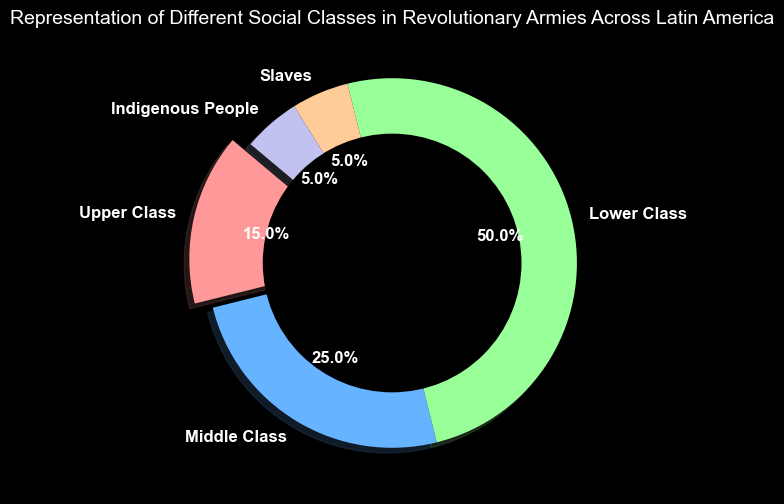What percentage of the revolutionary armies were comprised of the Lower Class? By looking at the figure, the section labeled "Lower Class" shows the percentage representation. The slice labeled "Lower Class" is marked with a certain percentage.
Answer: 50% Which social class had the smallest representation in the revolutionary armies? The figure shows various slices with different sizes corresponding to percentages. The smallest slices are those representing "Slaves" and "Indigenous People," both having the smallest percentage.
Answer: Slaves and Indigenous People Which had a higher representation in the revolutionary armies: Upper Class or Middle Class? By observing the slices, the "Upper Class" (15%) and "Middle Class" (25%) can be compared. The "Middle Class" slice is larger.
Answer: Middle Class What is the combined percentage of Slaves and Indigenous People in the revolutionary armies? Adding the percentages of the sections labeled "Slaves" and "Indigenous People" (both 5%), the total can be computed.
Answer: 10% How much larger is the representation of the Lower Class compared to the Upper Class in the revolutionary armies? Subtract the percentage of the "Upper Class" (15%) from that of the "Lower Class" (50%). The difference will give the answer.
Answer: 35% What fraction of the entire representation in the pie chart do the Middle Class and Lower Class together form? Adding the percentages of "Middle Class" (25%) and "Lower Class" (50%), then converting the result to a fraction of the total 100%.
Answer: 3/4 Which social class is represented by the red color in the pie chart? By looking at the visual attributes, the slice with the red color corresponds to the social class labeled "Upper Class," exploded for emphasis.
Answer: Upper Class How do the combined percentages of the Slaves and Indigenous People compare to the Upper Class? First, calculate the combined percentage for "Slaves" and "Indigenous People" (5% + 5% = 10%), then compare it with "Upper Class" (15%).
Answer: 5% less 